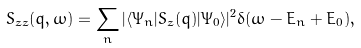<formula> <loc_0><loc_0><loc_500><loc_500>S _ { z z } ( q , \omega ) = \sum _ { n } | \langle \Psi _ { n } | S _ { z } ( q ) | \Psi _ { 0 } \rangle | ^ { 2 } \delta ( \omega - E _ { n } + E _ { 0 } ) ,</formula> 